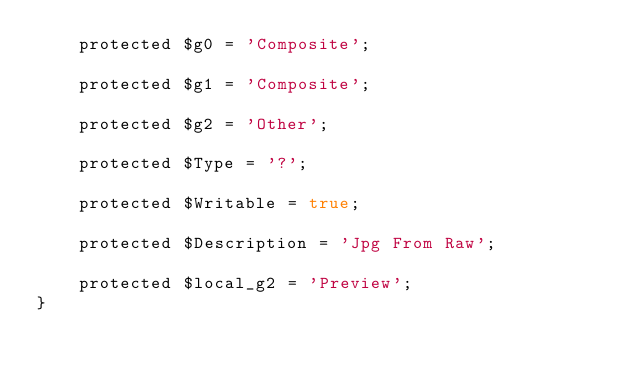<code> <loc_0><loc_0><loc_500><loc_500><_PHP_>    protected $g0 = 'Composite';

    protected $g1 = 'Composite';

    protected $g2 = 'Other';

    protected $Type = '?';

    protected $Writable = true;

    protected $Description = 'Jpg From Raw';

    protected $local_g2 = 'Preview';
}
</code> 